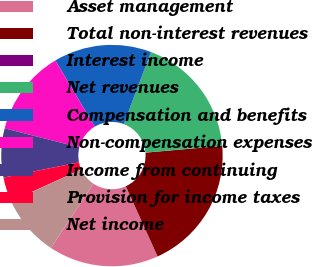Convert chart. <chart><loc_0><loc_0><loc_500><loc_500><pie_chart><fcel>Asset management<fcel>Total non-interest revenues<fcel>Interest income<fcel>Net revenues<fcel>Compensation and benefits<fcel>Non-compensation expenses<fcel>Income from continuing<fcel>Provision for income taxes<fcel>Net income<nl><fcel>16.06%<fcel>19.63%<fcel>0.02%<fcel>17.85%<fcel>14.28%<fcel>12.5%<fcel>7.15%<fcel>3.58%<fcel>8.93%<nl></chart> 